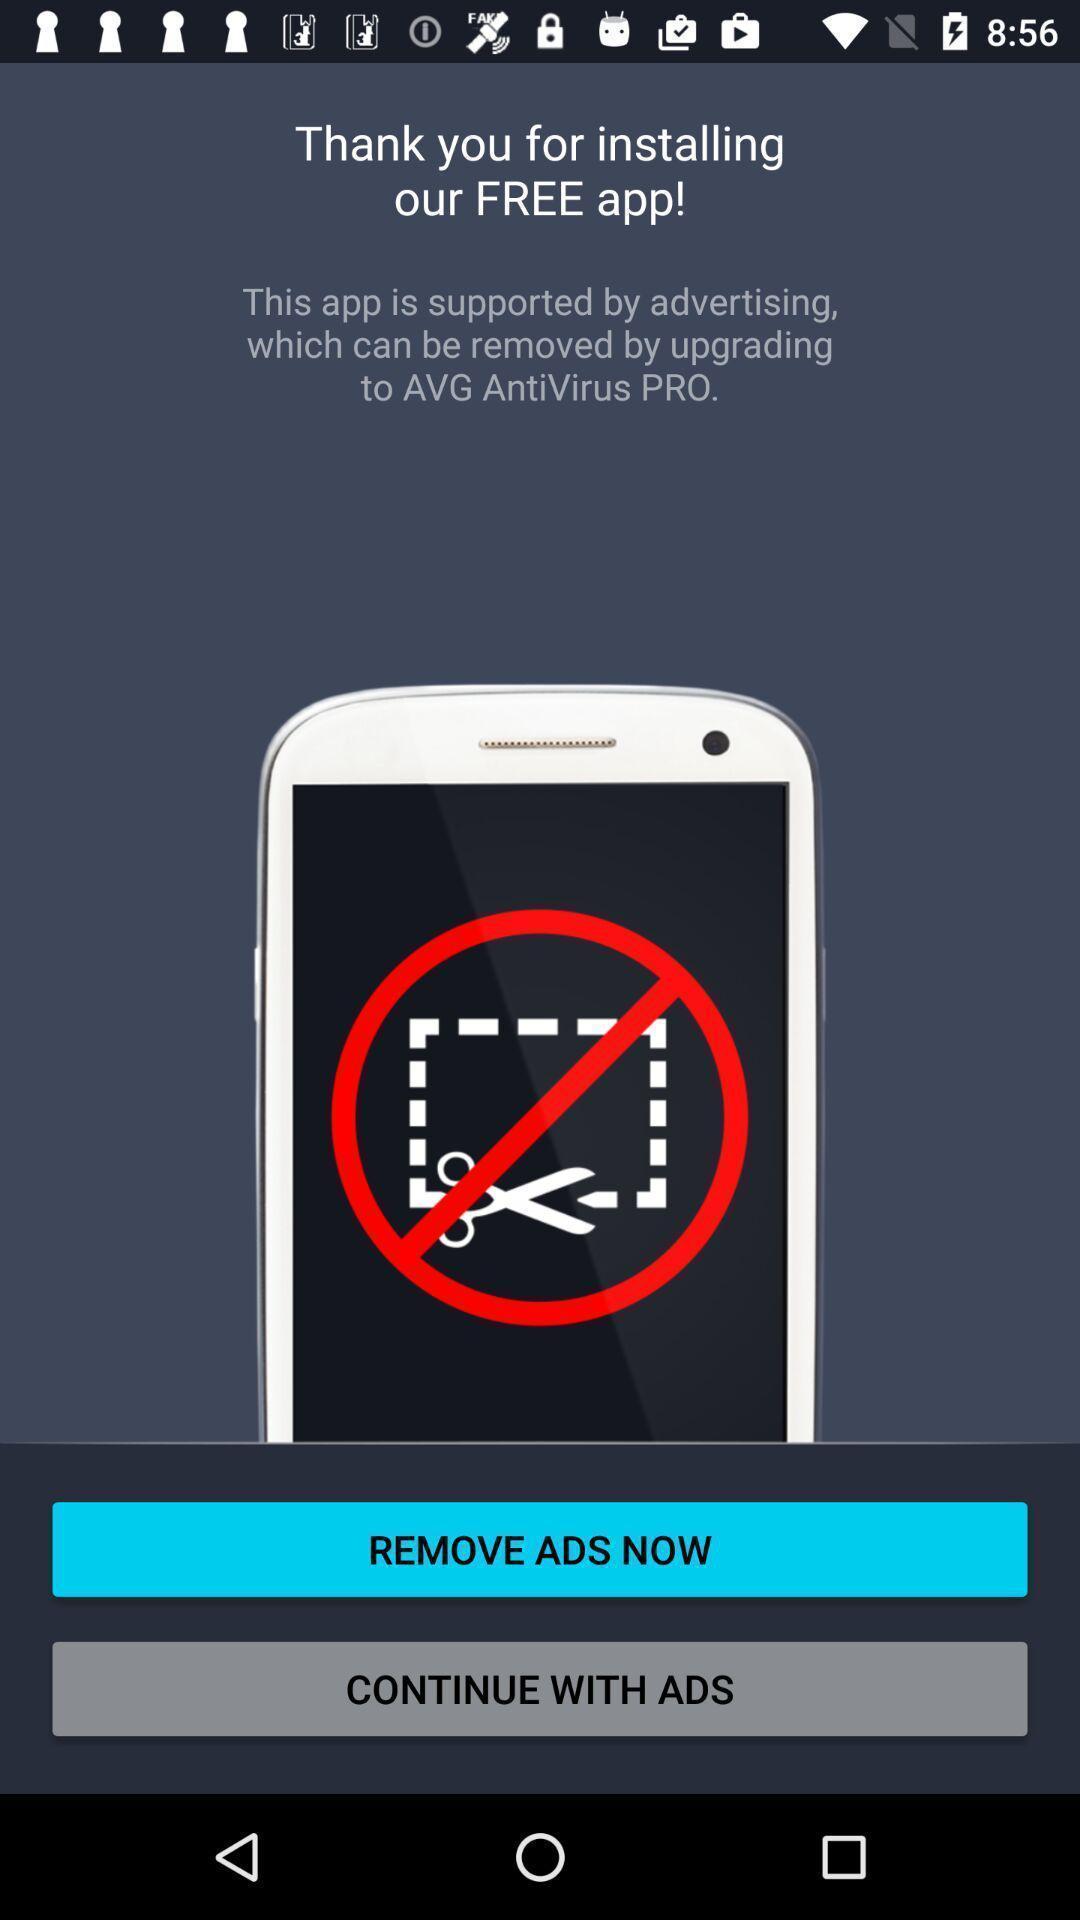Explain what's happening in this screen capture. Welcome page for a antivirus app. 